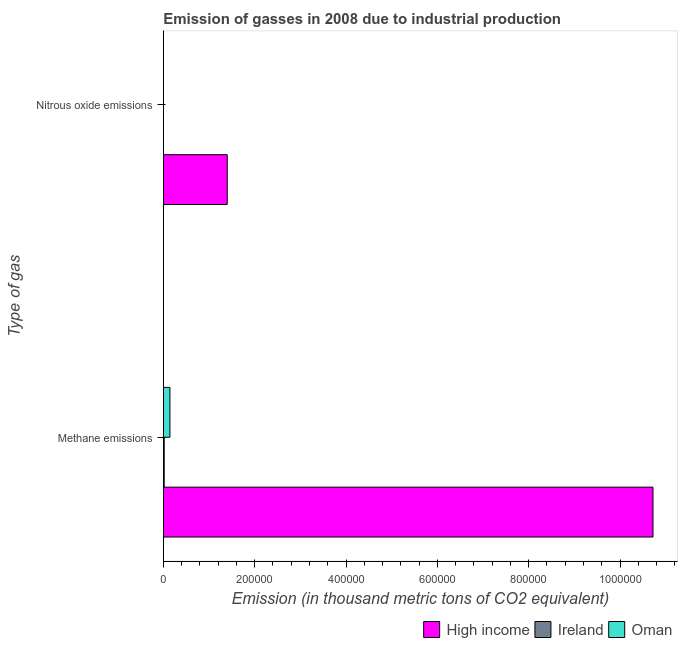How many groups of bars are there?
Your answer should be compact. 2. Are the number of bars per tick equal to the number of legend labels?
Ensure brevity in your answer.  Yes. Are the number of bars on each tick of the Y-axis equal?
Keep it short and to the point. Yes. What is the label of the 2nd group of bars from the top?
Ensure brevity in your answer.  Methane emissions. What is the amount of methane emissions in Oman?
Keep it short and to the point. 1.45e+04. Across all countries, what is the maximum amount of methane emissions?
Offer a very short reply. 1.07e+06. Across all countries, what is the minimum amount of methane emissions?
Offer a terse response. 1967.1. In which country was the amount of nitrous oxide emissions maximum?
Offer a very short reply. High income. In which country was the amount of nitrous oxide emissions minimum?
Offer a very short reply. Oman. What is the total amount of nitrous oxide emissions in the graph?
Provide a short and direct response. 1.40e+05. What is the difference between the amount of nitrous oxide emissions in High income and that in Oman?
Provide a short and direct response. 1.40e+05. What is the difference between the amount of methane emissions in Ireland and the amount of nitrous oxide emissions in High income?
Offer a terse response. -1.38e+05. What is the average amount of methane emissions per country?
Your answer should be very brief. 3.63e+05. What is the difference between the amount of nitrous oxide emissions and amount of methane emissions in High income?
Provide a short and direct response. -9.32e+05. In how many countries, is the amount of nitrous oxide emissions greater than 600000 thousand metric tons?
Offer a very short reply. 0. What is the ratio of the amount of nitrous oxide emissions in Ireland to that in High income?
Provide a short and direct response. 0. Is the amount of nitrous oxide emissions in Oman less than that in High income?
Keep it short and to the point. Yes. In how many countries, is the amount of methane emissions greater than the average amount of methane emissions taken over all countries?
Your answer should be very brief. 1. What does the 1st bar from the top in Methane emissions represents?
Offer a terse response. Oman. How many bars are there?
Keep it short and to the point. 6. Are all the bars in the graph horizontal?
Keep it short and to the point. Yes. What is the difference between two consecutive major ticks on the X-axis?
Give a very brief answer. 2.00e+05. Are the values on the major ticks of X-axis written in scientific E-notation?
Your answer should be very brief. No. Does the graph contain grids?
Offer a very short reply. No. How many legend labels are there?
Make the answer very short. 3. How are the legend labels stacked?
Provide a succinct answer. Horizontal. What is the title of the graph?
Your response must be concise. Emission of gasses in 2008 due to industrial production. Does "Lesotho" appear as one of the legend labels in the graph?
Make the answer very short. No. What is the label or title of the X-axis?
Keep it short and to the point. Emission (in thousand metric tons of CO2 equivalent). What is the label or title of the Y-axis?
Offer a terse response. Type of gas. What is the Emission (in thousand metric tons of CO2 equivalent) in High income in Methane emissions?
Offer a terse response. 1.07e+06. What is the Emission (in thousand metric tons of CO2 equivalent) in Ireland in Methane emissions?
Your answer should be very brief. 1967.1. What is the Emission (in thousand metric tons of CO2 equivalent) of Oman in Methane emissions?
Give a very brief answer. 1.45e+04. What is the Emission (in thousand metric tons of CO2 equivalent) of High income in Nitrous oxide emissions?
Your answer should be very brief. 1.40e+05. What is the Emission (in thousand metric tons of CO2 equivalent) in Ireland in Nitrous oxide emissions?
Your answer should be very brief. 340.5. What is the Emission (in thousand metric tons of CO2 equivalent) of Oman in Nitrous oxide emissions?
Ensure brevity in your answer.  90.3. Across all Type of gas, what is the maximum Emission (in thousand metric tons of CO2 equivalent) of High income?
Give a very brief answer. 1.07e+06. Across all Type of gas, what is the maximum Emission (in thousand metric tons of CO2 equivalent) of Ireland?
Keep it short and to the point. 1967.1. Across all Type of gas, what is the maximum Emission (in thousand metric tons of CO2 equivalent) of Oman?
Provide a succinct answer. 1.45e+04. Across all Type of gas, what is the minimum Emission (in thousand metric tons of CO2 equivalent) of High income?
Your response must be concise. 1.40e+05. Across all Type of gas, what is the minimum Emission (in thousand metric tons of CO2 equivalent) of Ireland?
Offer a terse response. 340.5. Across all Type of gas, what is the minimum Emission (in thousand metric tons of CO2 equivalent) in Oman?
Your answer should be very brief. 90.3. What is the total Emission (in thousand metric tons of CO2 equivalent) of High income in the graph?
Your response must be concise. 1.21e+06. What is the total Emission (in thousand metric tons of CO2 equivalent) of Ireland in the graph?
Your response must be concise. 2307.6. What is the total Emission (in thousand metric tons of CO2 equivalent) of Oman in the graph?
Offer a very short reply. 1.46e+04. What is the difference between the Emission (in thousand metric tons of CO2 equivalent) of High income in Methane emissions and that in Nitrous oxide emissions?
Provide a succinct answer. 9.32e+05. What is the difference between the Emission (in thousand metric tons of CO2 equivalent) of Ireland in Methane emissions and that in Nitrous oxide emissions?
Offer a very short reply. 1626.6. What is the difference between the Emission (in thousand metric tons of CO2 equivalent) in Oman in Methane emissions and that in Nitrous oxide emissions?
Give a very brief answer. 1.44e+04. What is the difference between the Emission (in thousand metric tons of CO2 equivalent) of High income in Methane emissions and the Emission (in thousand metric tons of CO2 equivalent) of Ireland in Nitrous oxide emissions?
Offer a very short reply. 1.07e+06. What is the difference between the Emission (in thousand metric tons of CO2 equivalent) of High income in Methane emissions and the Emission (in thousand metric tons of CO2 equivalent) of Oman in Nitrous oxide emissions?
Your response must be concise. 1.07e+06. What is the difference between the Emission (in thousand metric tons of CO2 equivalent) of Ireland in Methane emissions and the Emission (in thousand metric tons of CO2 equivalent) of Oman in Nitrous oxide emissions?
Offer a terse response. 1876.8. What is the average Emission (in thousand metric tons of CO2 equivalent) of High income per Type of gas?
Offer a very short reply. 6.06e+05. What is the average Emission (in thousand metric tons of CO2 equivalent) of Ireland per Type of gas?
Provide a succinct answer. 1153.8. What is the average Emission (in thousand metric tons of CO2 equivalent) of Oman per Type of gas?
Offer a very short reply. 7289.75. What is the difference between the Emission (in thousand metric tons of CO2 equivalent) of High income and Emission (in thousand metric tons of CO2 equivalent) of Ireland in Methane emissions?
Your answer should be compact. 1.07e+06. What is the difference between the Emission (in thousand metric tons of CO2 equivalent) of High income and Emission (in thousand metric tons of CO2 equivalent) of Oman in Methane emissions?
Keep it short and to the point. 1.06e+06. What is the difference between the Emission (in thousand metric tons of CO2 equivalent) of Ireland and Emission (in thousand metric tons of CO2 equivalent) of Oman in Methane emissions?
Make the answer very short. -1.25e+04. What is the difference between the Emission (in thousand metric tons of CO2 equivalent) of High income and Emission (in thousand metric tons of CO2 equivalent) of Ireland in Nitrous oxide emissions?
Provide a succinct answer. 1.40e+05. What is the difference between the Emission (in thousand metric tons of CO2 equivalent) of High income and Emission (in thousand metric tons of CO2 equivalent) of Oman in Nitrous oxide emissions?
Your answer should be very brief. 1.40e+05. What is the difference between the Emission (in thousand metric tons of CO2 equivalent) of Ireland and Emission (in thousand metric tons of CO2 equivalent) of Oman in Nitrous oxide emissions?
Offer a terse response. 250.2. What is the ratio of the Emission (in thousand metric tons of CO2 equivalent) in High income in Methane emissions to that in Nitrous oxide emissions?
Give a very brief answer. 7.66. What is the ratio of the Emission (in thousand metric tons of CO2 equivalent) in Ireland in Methane emissions to that in Nitrous oxide emissions?
Your response must be concise. 5.78. What is the ratio of the Emission (in thousand metric tons of CO2 equivalent) in Oman in Methane emissions to that in Nitrous oxide emissions?
Provide a succinct answer. 160.46. What is the difference between the highest and the second highest Emission (in thousand metric tons of CO2 equivalent) of High income?
Your answer should be very brief. 9.32e+05. What is the difference between the highest and the second highest Emission (in thousand metric tons of CO2 equivalent) of Ireland?
Provide a short and direct response. 1626.6. What is the difference between the highest and the second highest Emission (in thousand metric tons of CO2 equivalent) of Oman?
Offer a terse response. 1.44e+04. What is the difference between the highest and the lowest Emission (in thousand metric tons of CO2 equivalent) of High income?
Provide a short and direct response. 9.32e+05. What is the difference between the highest and the lowest Emission (in thousand metric tons of CO2 equivalent) in Ireland?
Keep it short and to the point. 1626.6. What is the difference between the highest and the lowest Emission (in thousand metric tons of CO2 equivalent) in Oman?
Your response must be concise. 1.44e+04. 